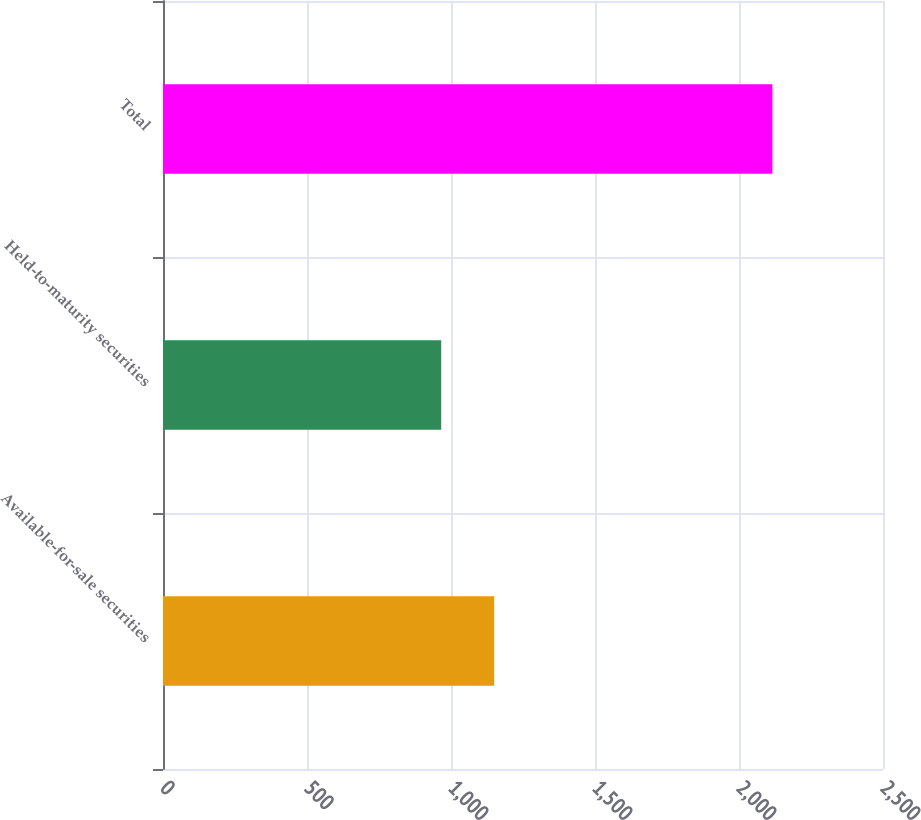Convert chart. <chart><loc_0><loc_0><loc_500><loc_500><bar_chart><fcel>Available-for-sale securities<fcel>Held-to-maturity securities<fcel>Total<nl><fcel>1150<fcel>966<fcel>2116<nl></chart> 